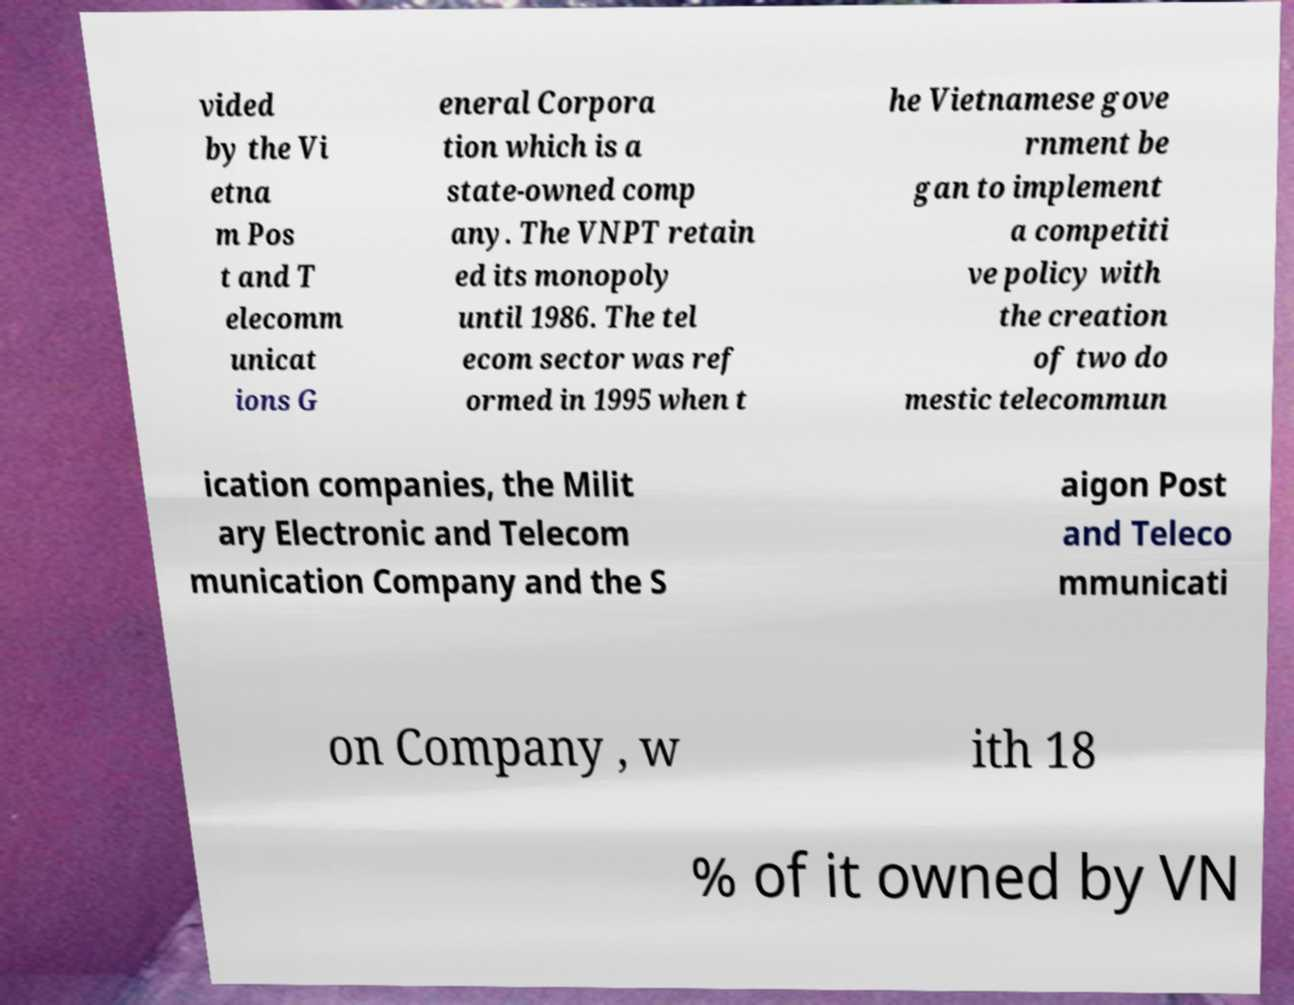Can you accurately transcribe the text from the provided image for me? vided by the Vi etna m Pos t and T elecomm unicat ions G eneral Corpora tion which is a state-owned comp any. The VNPT retain ed its monopoly until 1986. The tel ecom sector was ref ormed in 1995 when t he Vietnamese gove rnment be gan to implement a competiti ve policy with the creation of two do mestic telecommun ication companies, the Milit ary Electronic and Telecom munication Company and the S aigon Post and Teleco mmunicati on Company , w ith 18 % of it owned by VN 